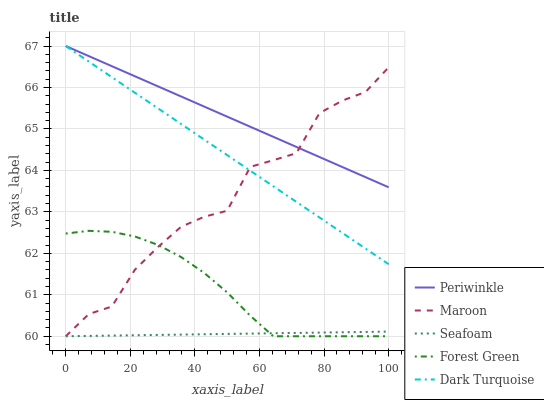Does Seafoam have the minimum area under the curve?
Answer yes or no. Yes. Does Periwinkle have the maximum area under the curve?
Answer yes or no. Yes. Does Forest Green have the minimum area under the curve?
Answer yes or no. No. Does Forest Green have the maximum area under the curve?
Answer yes or no. No. Is Dark Turquoise the smoothest?
Answer yes or no. Yes. Is Maroon the roughest?
Answer yes or no. Yes. Is Forest Green the smoothest?
Answer yes or no. No. Is Forest Green the roughest?
Answer yes or no. No. Does Periwinkle have the lowest value?
Answer yes or no. No. Does Forest Green have the highest value?
Answer yes or no. No. Is Forest Green less than Dark Turquoise?
Answer yes or no. Yes. Is Dark Turquoise greater than Forest Green?
Answer yes or no. Yes. Does Forest Green intersect Dark Turquoise?
Answer yes or no. No. 